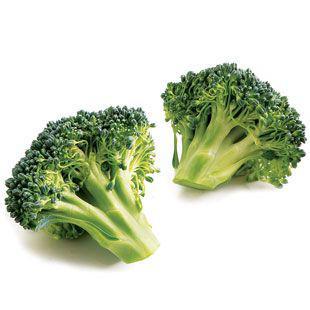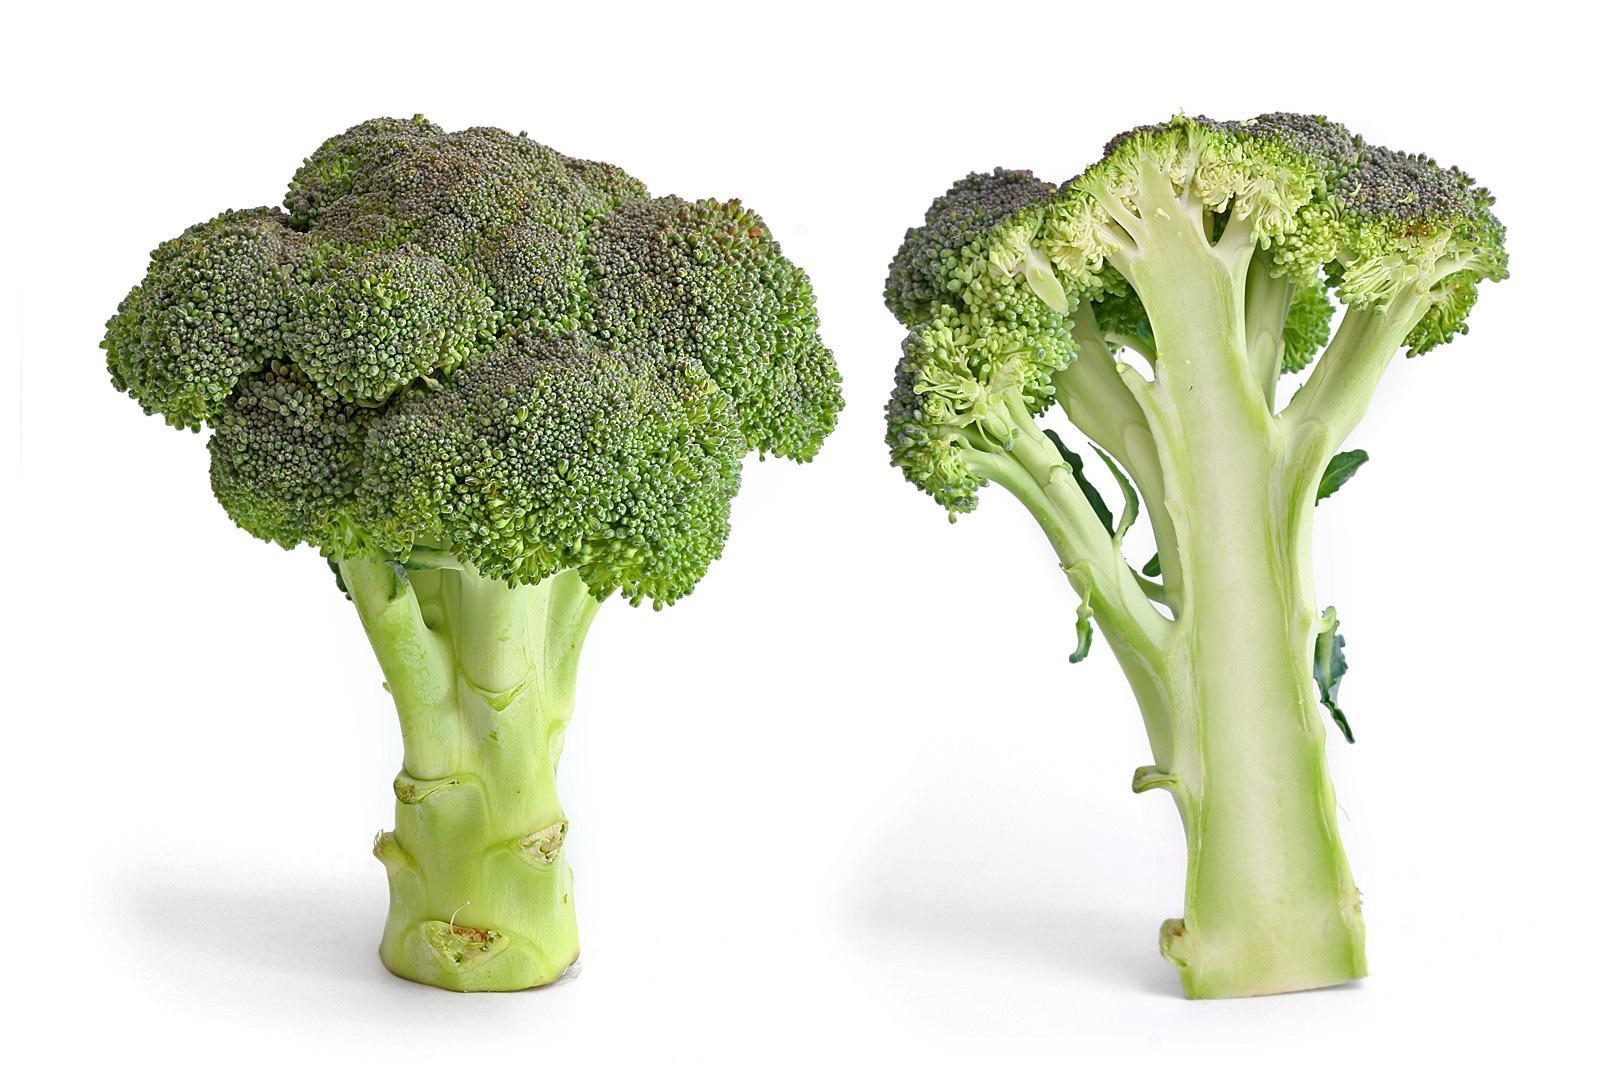The first image is the image on the left, the second image is the image on the right. Given the left and right images, does the statement "All of the images only feature broccoli pieces and nothing else." hold true? Answer yes or no. Yes. The first image is the image on the left, the second image is the image on the right. Evaluate the accuracy of this statement regarding the images: "One image shows broccoli florets that are on some type of roundish item.". Is it true? Answer yes or no. No. 